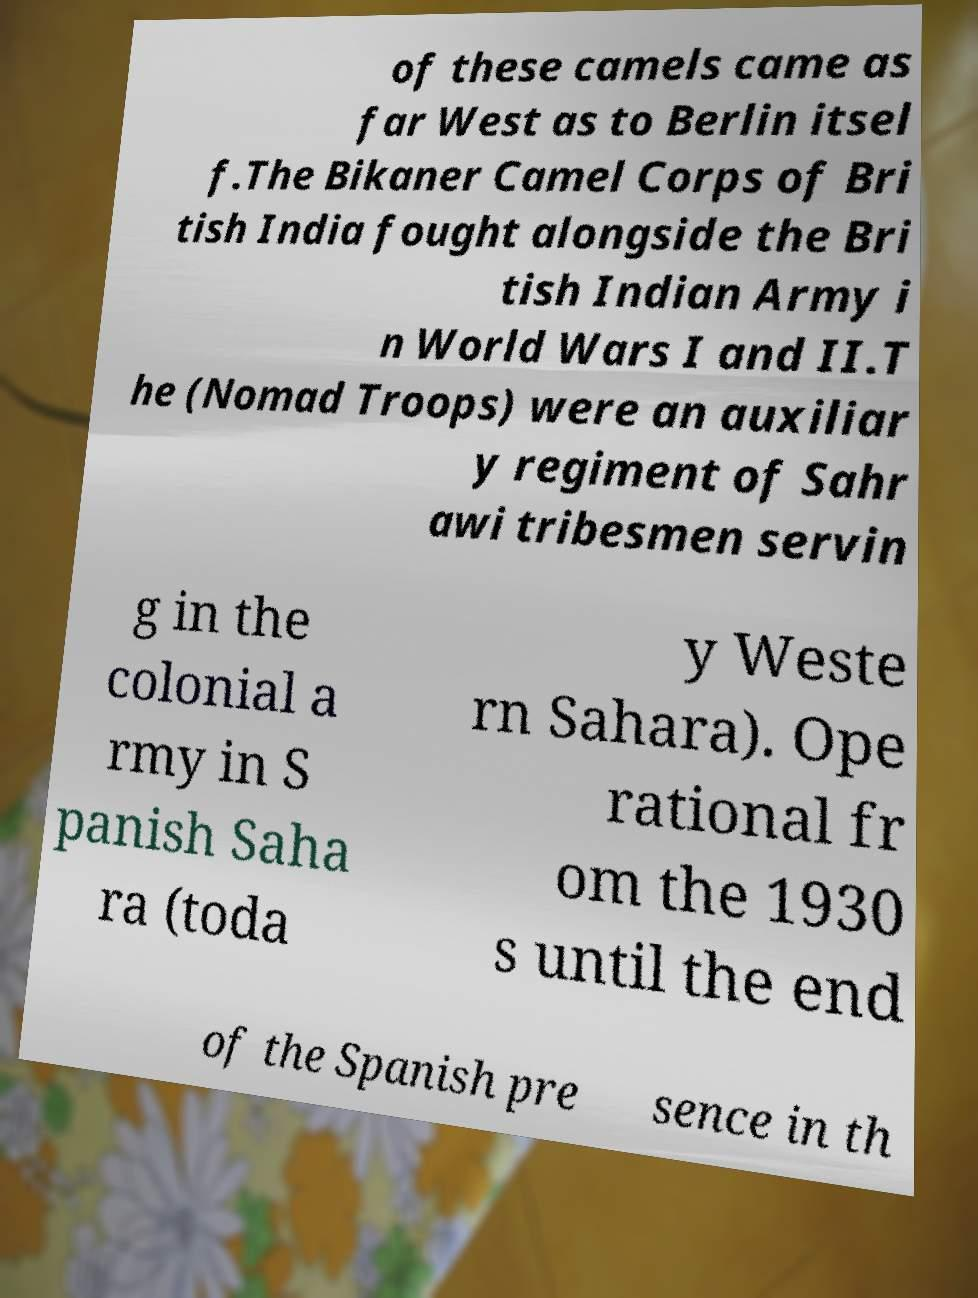What messages or text are displayed in this image? I need them in a readable, typed format. of these camels came as far West as to Berlin itsel f.The Bikaner Camel Corps of Bri tish India fought alongside the Bri tish Indian Army i n World Wars I and II.T he (Nomad Troops) were an auxiliar y regiment of Sahr awi tribesmen servin g in the colonial a rmy in S panish Saha ra (toda y Weste rn Sahara). Ope rational fr om the 1930 s until the end of the Spanish pre sence in th 